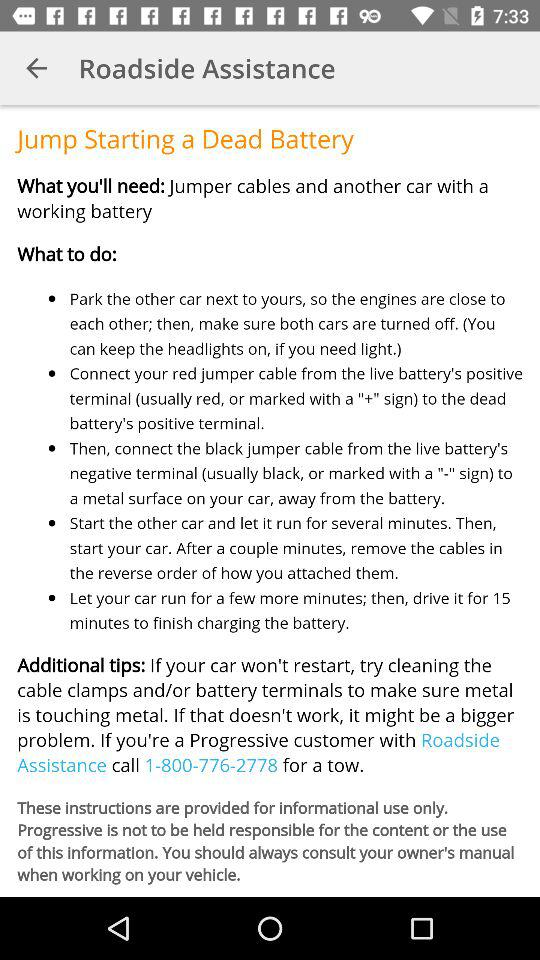What is the customer service number given for towing in "Roadside Assistance"? The customer service number is 1-800-776-2778. 